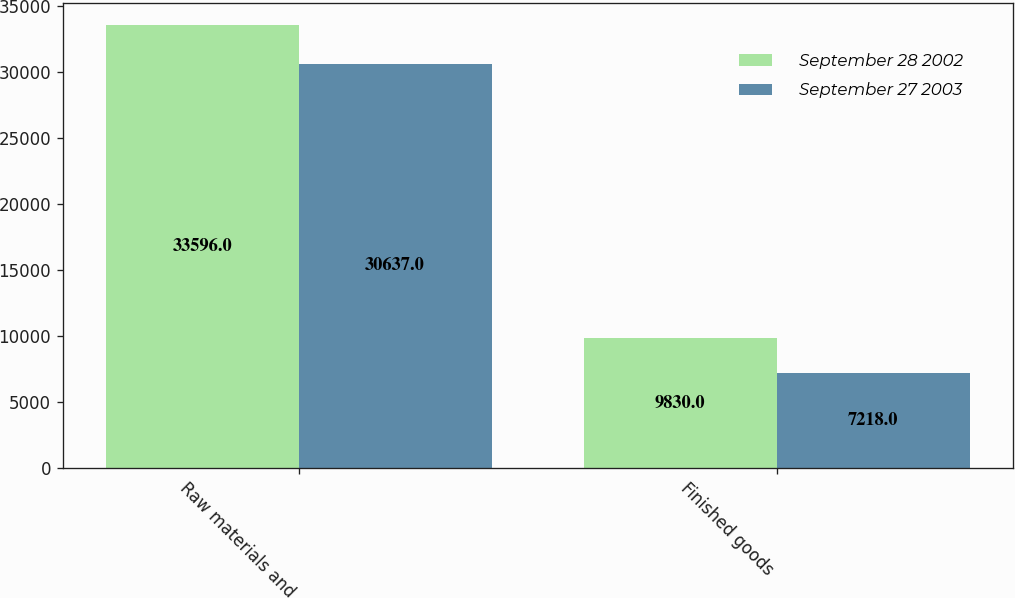Convert chart to OTSL. <chart><loc_0><loc_0><loc_500><loc_500><stacked_bar_chart><ecel><fcel>Raw materials and<fcel>Finished goods<nl><fcel>September 28 2002<fcel>33596<fcel>9830<nl><fcel>September 27 2003<fcel>30637<fcel>7218<nl></chart> 